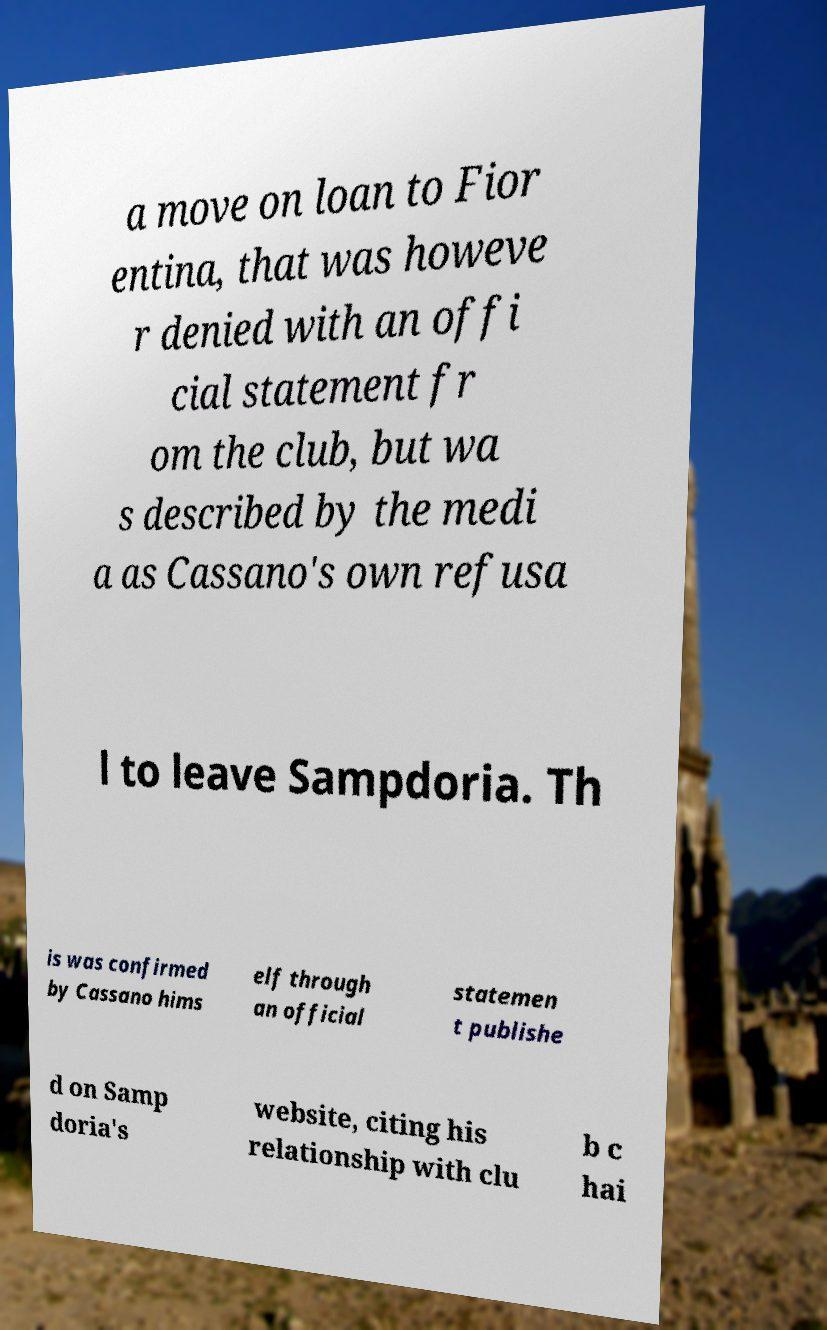What messages or text are displayed in this image? I need them in a readable, typed format. a move on loan to Fior entina, that was howeve r denied with an offi cial statement fr om the club, but wa s described by the medi a as Cassano's own refusa l to leave Sampdoria. Th is was confirmed by Cassano hims elf through an official statemen t publishe d on Samp doria's website, citing his relationship with clu b c hai 